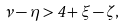<formula> <loc_0><loc_0><loc_500><loc_500>\nu - \eta > 4 + \xi - \zeta ,</formula> 